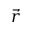<formula> <loc_0><loc_0><loc_500><loc_500>\vec { r }</formula> 